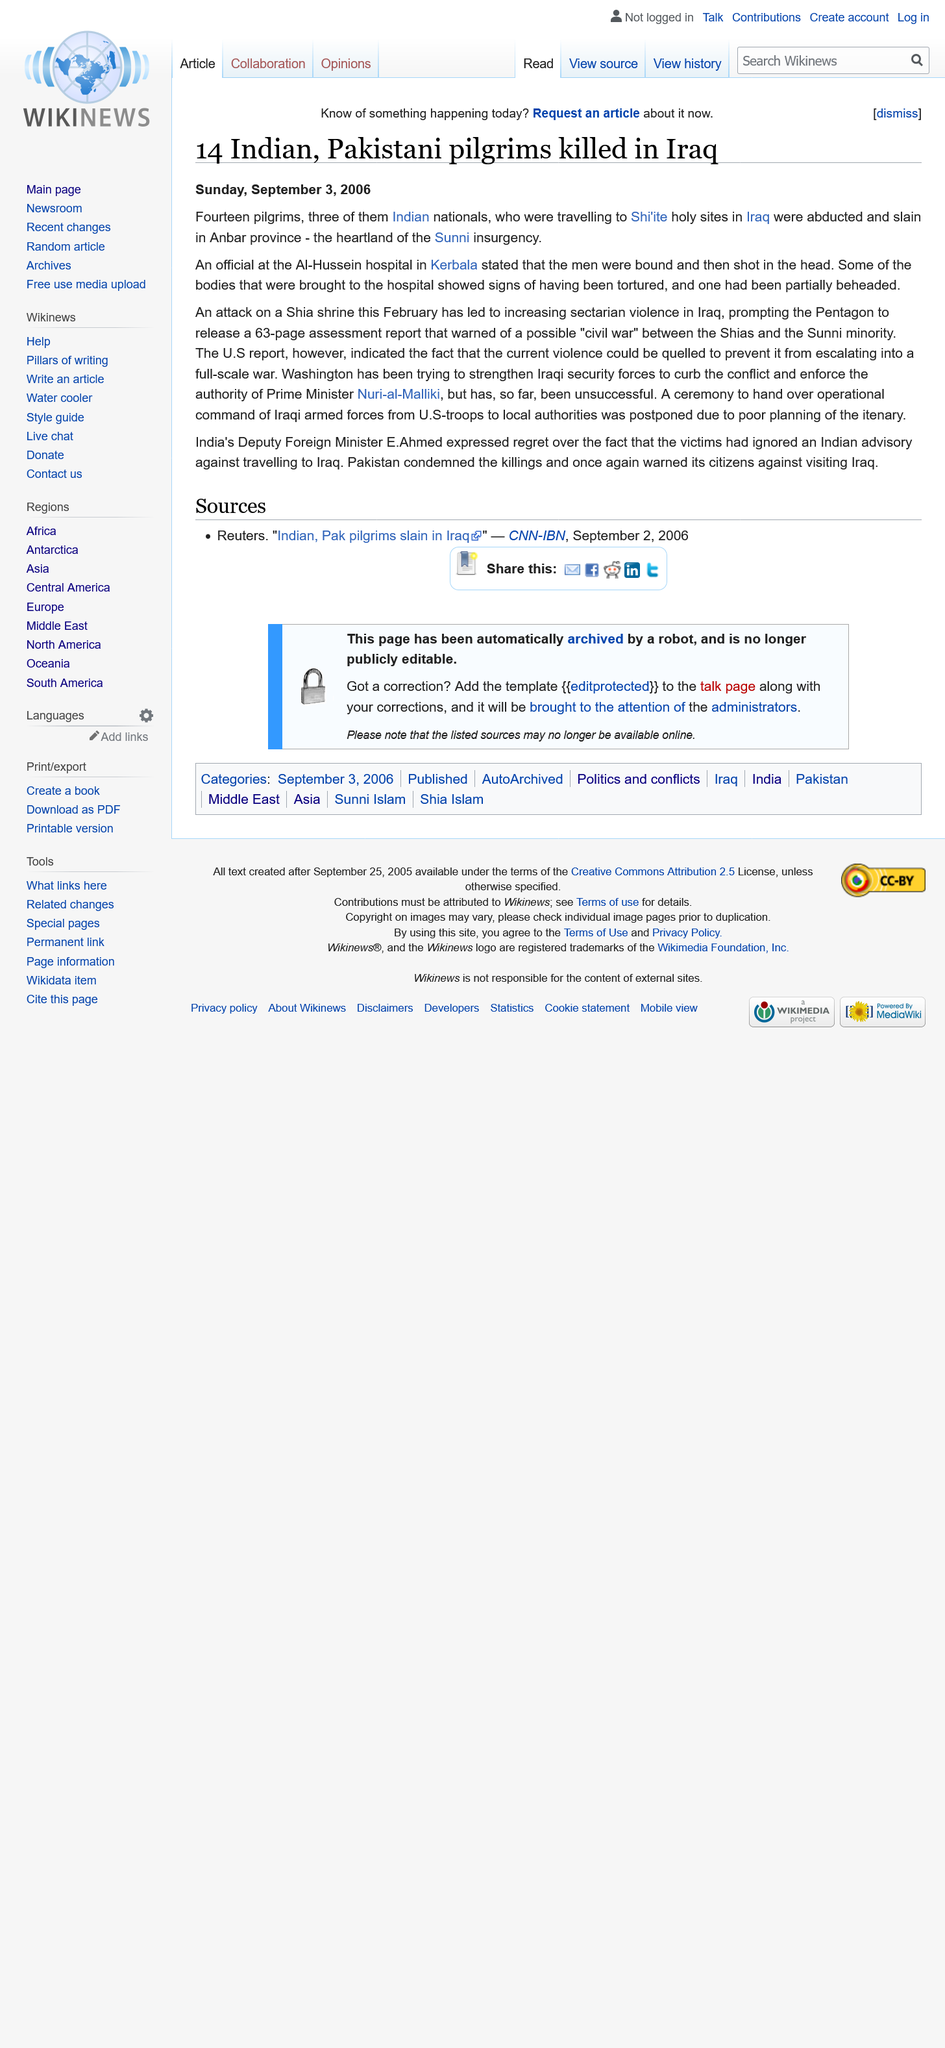Draw attention to some important aspects in this diagram. The victims were brought to the Al-Hussein Hospital in Kerbala, which is a hospital located in Kerbala, Iraq. A total of 14 Pakistani and Indian pilgrims were killed in Iraq. In the Anbar province, the location of the slain victims was (where they were). 